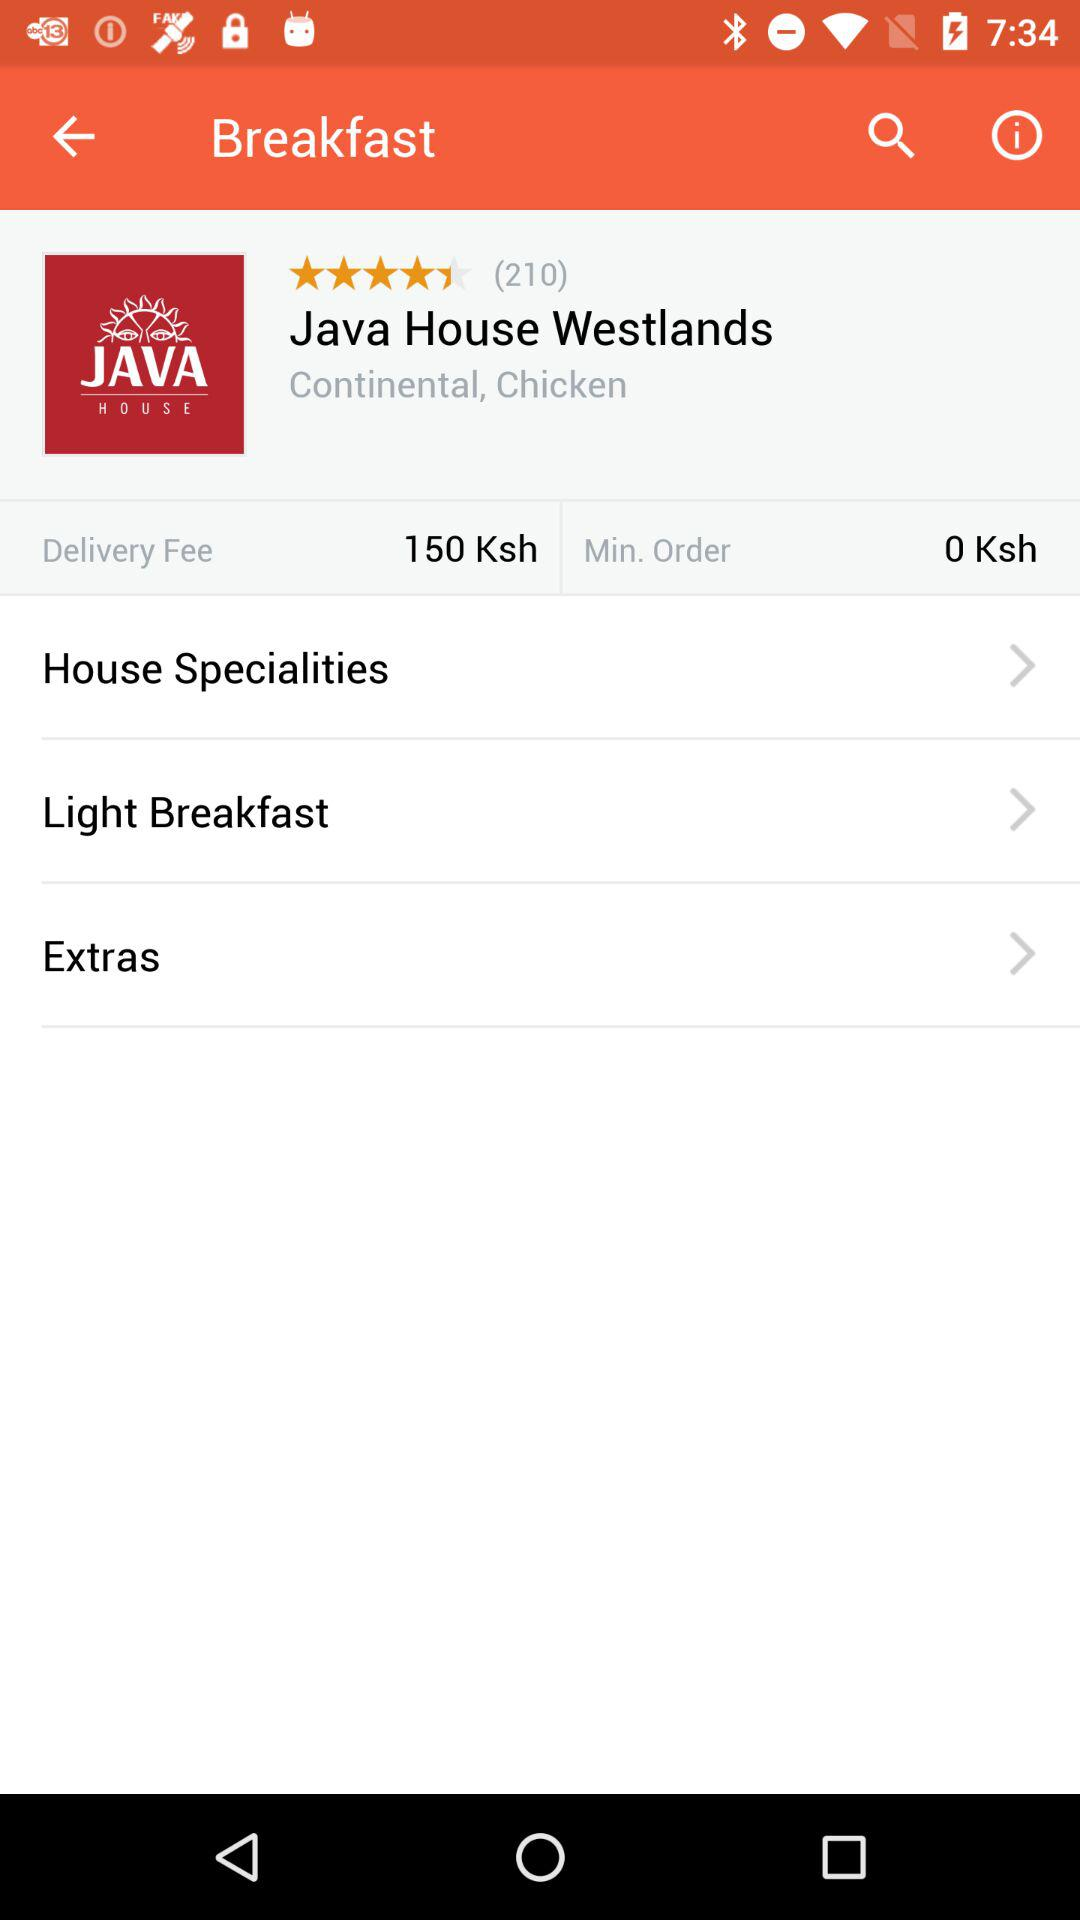How much is the minimum order?
Answer the question using a single word or phrase. 0 Ksh 